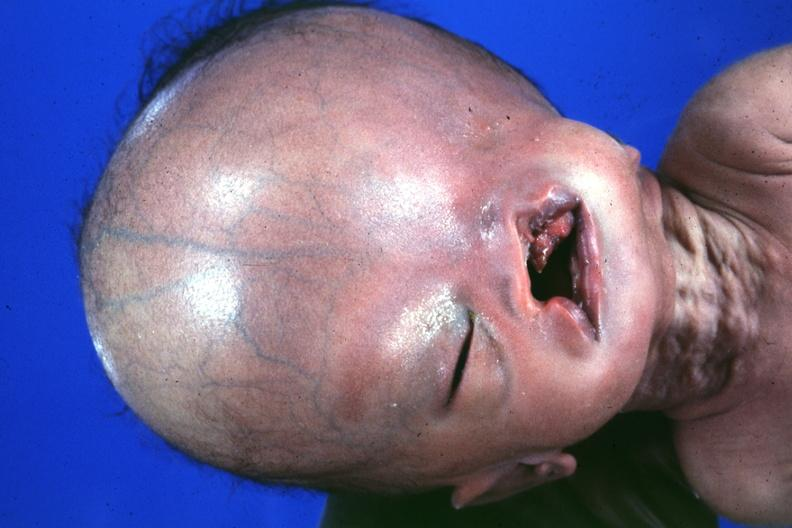does absence of palpebral fissure cleft palate see protocol for details?
Answer the question using a single word or phrase. Yes 